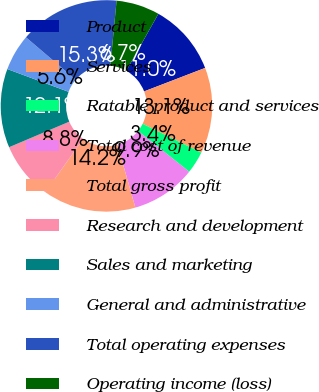<chart> <loc_0><loc_0><loc_500><loc_500><pie_chart><fcel>Product<fcel>Services<fcel>Ratable product and services<fcel>Total cost of revenue<fcel>Total gross profit<fcel>Research and development<fcel>Sales and marketing<fcel>General and administrative<fcel>Total operating expenses<fcel>Operating income (loss)<nl><fcel>10.97%<fcel>13.13%<fcel>3.41%<fcel>9.89%<fcel>14.21%<fcel>8.81%<fcel>12.05%<fcel>5.57%<fcel>15.29%<fcel>6.65%<nl></chart> 